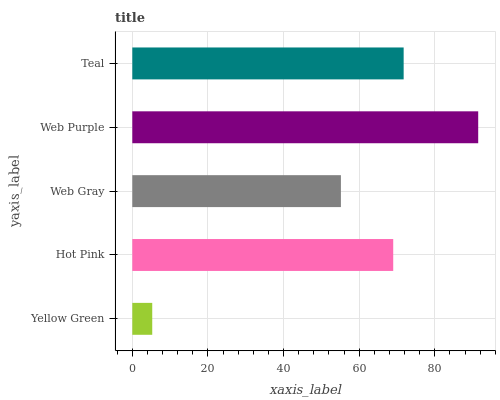Is Yellow Green the minimum?
Answer yes or no. Yes. Is Web Purple the maximum?
Answer yes or no. Yes. Is Hot Pink the minimum?
Answer yes or no. No. Is Hot Pink the maximum?
Answer yes or no. No. Is Hot Pink greater than Yellow Green?
Answer yes or no. Yes. Is Yellow Green less than Hot Pink?
Answer yes or no. Yes. Is Yellow Green greater than Hot Pink?
Answer yes or no. No. Is Hot Pink less than Yellow Green?
Answer yes or no. No. Is Hot Pink the high median?
Answer yes or no. Yes. Is Hot Pink the low median?
Answer yes or no. Yes. Is Teal the high median?
Answer yes or no. No. Is Web Purple the low median?
Answer yes or no. No. 